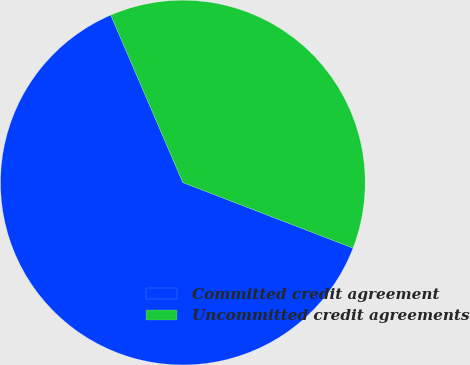Convert chart. <chart><loc_0><loc_0><loc_500><loc_500><pie_chart><fcel>Committed credit agreement<fcel>Uncommitted credit agreements<nl><fcel>62.68%<fcel>37.32%<nl></chart> 